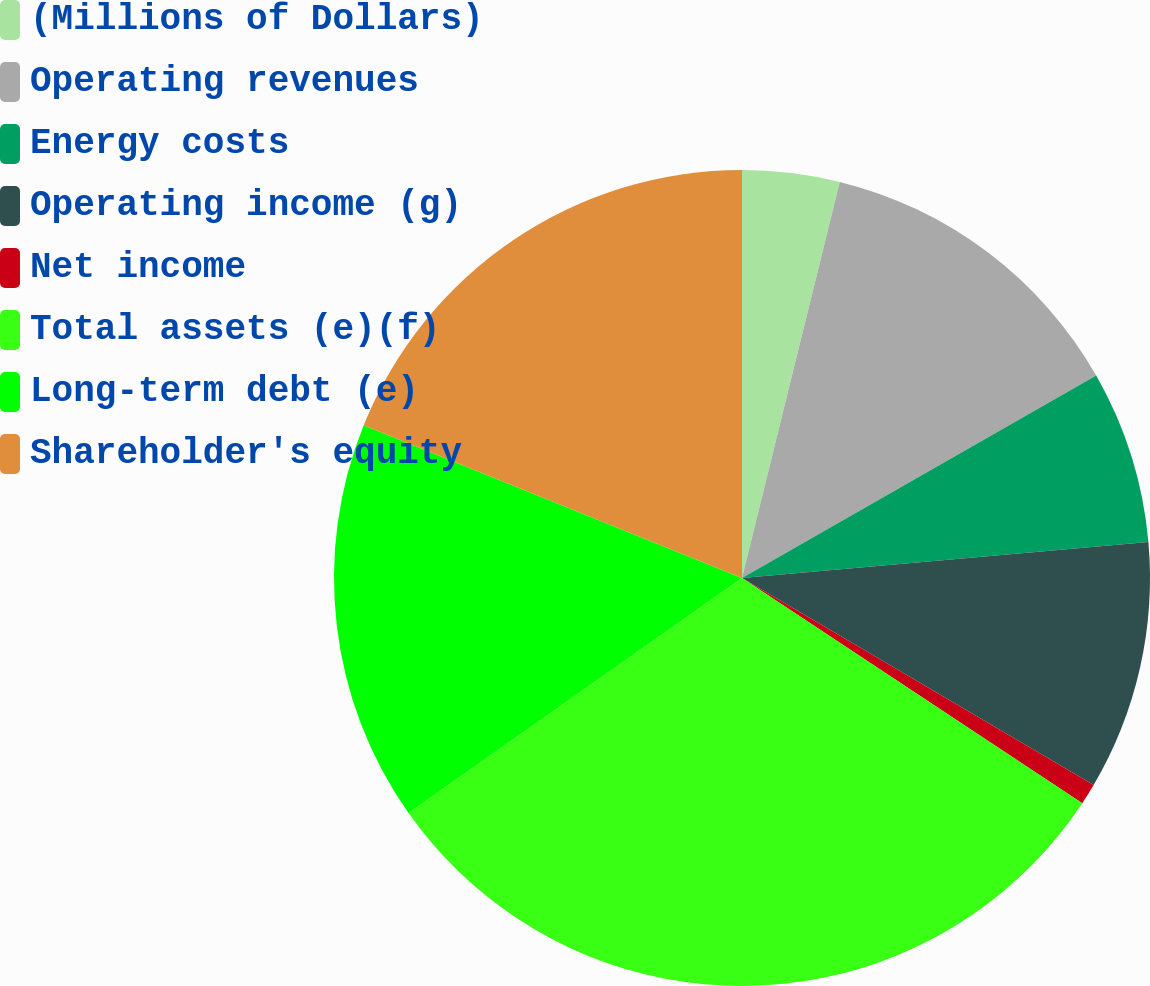<chart> <loc_0><loc_0><loc_500><loc_500><pie_chart><fcel>(Millions of Dollars)<fcel>Operating revenues<fcel>Energy costs<fcel>Operating income (g)<fcel>Net income<fcel>Total assets (e)(f)<fcel>Long-term debt (e)<fcel>Shareholder's equity<nl><fcel>3.85%<fcel>12.88%<fcel>6.86%<fcel>9.87%<fcel>0.84%<fcel>30.92%<fcel>15.88%<fcel>18.89%<nl></chart> 